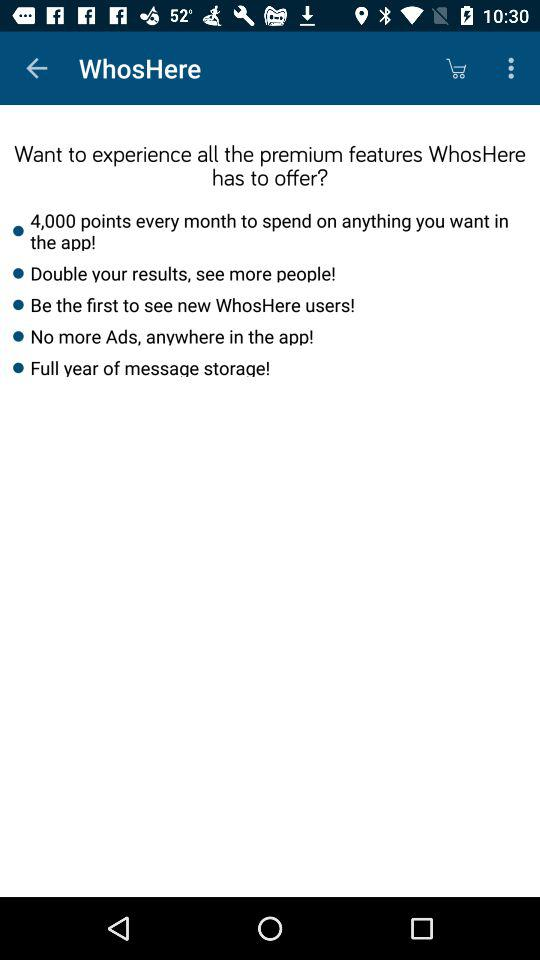How many points are offered per month? According to the image, the app offers 4,000 points every month which can be used on anything within the app itself. This points system is likely part of the premium features of the application designed to enhance user experience. 